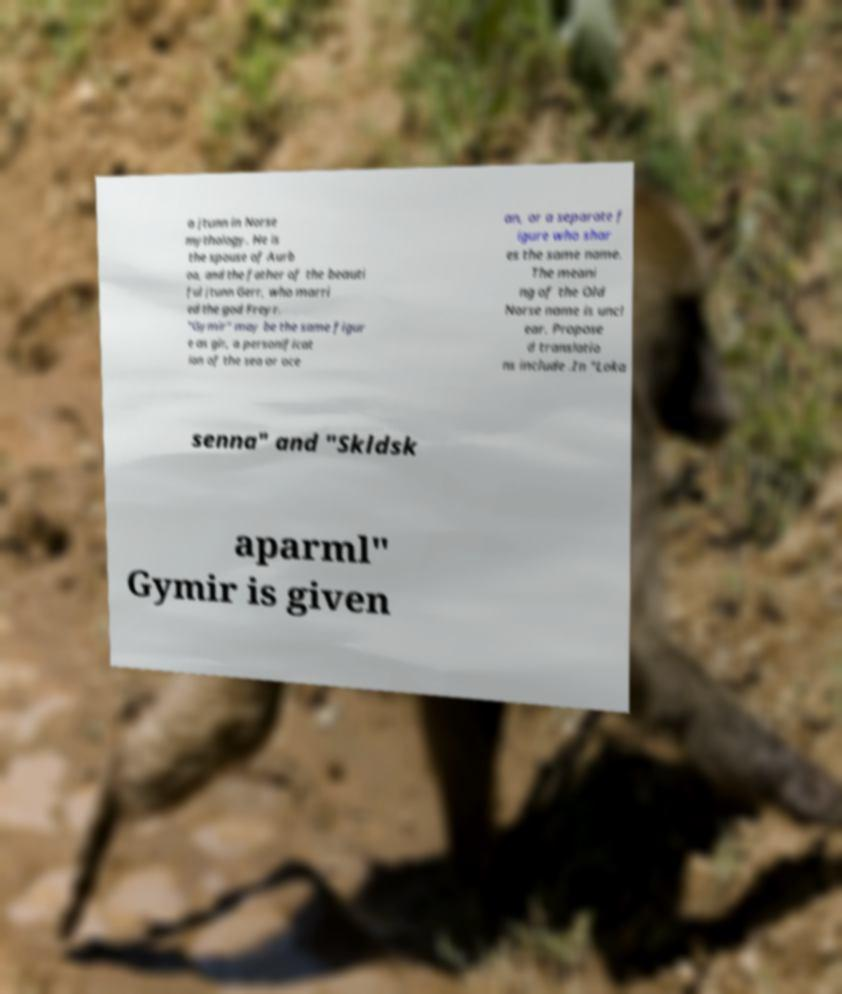For documentation purposes, I need the text within this image transcribed. Could you provide that? a jtunn in Norse mythology. He is the spouse of Aurb oa, and the father of the beauti ful jtunn Gerr, who marri ed the god Freyr. "Gymir" may be the same figur e as gir, a personificat ion of the sea or oce an, or a separate f igure who shar es the same name. The meani ng of the Old Norse name is uncl ear. Propose d translatio ns include .In "Loka senna" and "Skldsk aparml" Gymir is given 